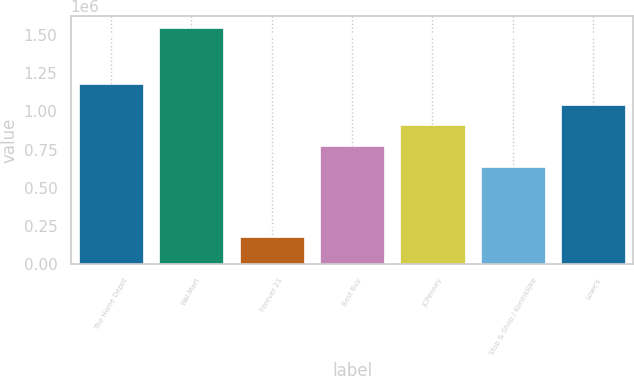Convert chart to OTSL. <chart><loc_0><loc_0><loc_500><loc_500><bar_chart><fcel>The Home Depot<fcel>Wal-Mart<fcel>Forever 21<fcel>Best Buy<fcel>JCPenney<fcel>Stop & Shop / Koninklijke<fcel>Lowe's<nl><fcel>1.1818e+06<fcel>1.547e+06<fcel>175000<fcel>770200<fcel>907400<fcel>633000<fcel>1.0446e+06<nl></chart> 